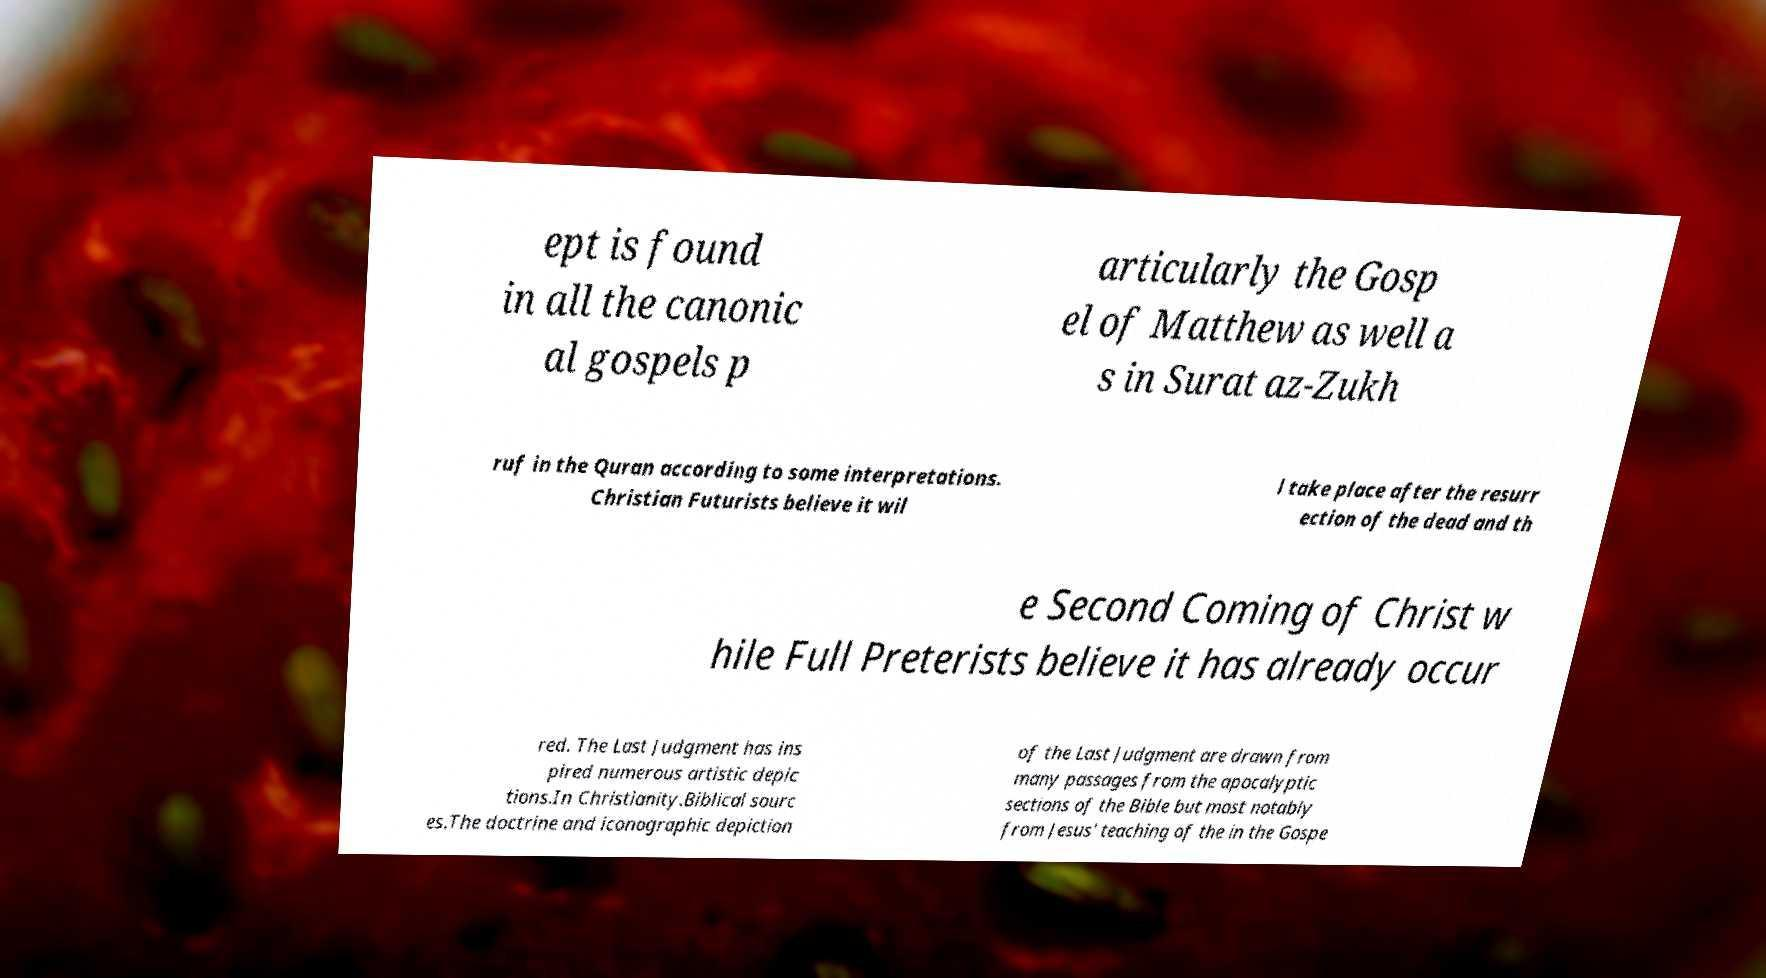Could you extract and type out the text from this image? ept is found in all the canonic al gospels p articularly the Gosp el of Matthew as well a s in Surat az-Zukh ruf in the Quran according to some interpretations. Christian Futurists believe it wil l take place after the resurr ection of the dead and th e Second Coming of Christ w hile Full Preterists believe it has already occur red. The Last Judgment has ins pired numerous artistic depic tions.In Christianity.Biblical sourc es.The doctrine and iconographic depiction of the Last Judgment are drawn from many passages from the apocalyptic sections of the Bible but most notably from Jesus' teaching of the in the Gospe 